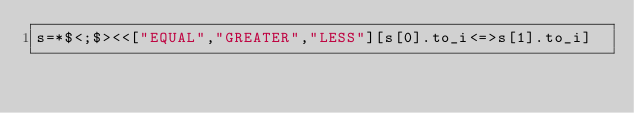Convert code to text. <code><loc_0><loc_0><loc_500><loc_500><_Ruby_>s=*$<;$><<["EQUAL","GREATER","LESS"][s[0].to_i<=>s[1].to_i]</code> 